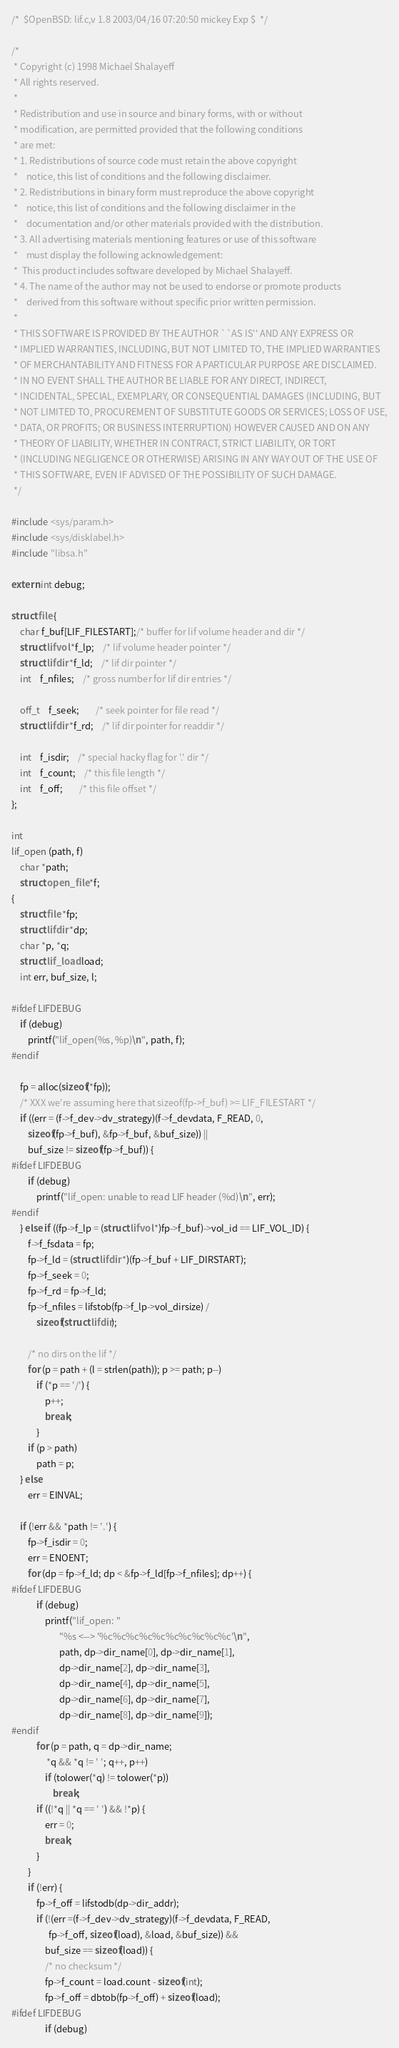<code> <loc_0><loc_0><loc_500><loc_500><_C_>/*	$OpenBSD: lif.c,v 1.8 2003/04/16 07:20:50 mickey Exp $	*/

/*
 * Copyright (c) 1998 Michael Shalayeff
 * All rights reserved.
 *
 * Redistribution and use in source and binary forms, with or without
 * modification, are permitted provided that the following conditions
 * are met:
 * 1. Redistributions of source code must retain the above copyright
 *    notice, this list of conditions and the following disclaimer.
 * 2. Redistributions in binary form must reproduce the above copyright
 *    notice, this list of conditions and the following disclaimer in the
 *    documentation and/or other materials provided with the distribution.
 * 3. All advertising materials mentioning features or use of this software
 *    must display the following acknowledgement:
 *	This product includes software developed by Michael Shalayeff.
 * 4. The name of the author may not be used to endorse or promote products
 *    derived from this software without specific prior written permission.
 *
 * THIS SOFTWARE IS PROVIDED BY THE AUTHOR ``AS IS'' AND ANY EXPRESS OR
 * IMPLIED WARRANTIES, INCLUDING, BUT NOT LIMITED TO, THE IMPLIED WARRANTIES
 * OF MERCHANTABILITY AND FITNESS FOR A PARTICULAR PURPOSE ARE DISCLAIMED.
 * IN NO EVENT SHALL THE AUTHOR BE LIABLE FOR ANY DIRECT, INDIRECT,
 * INCIDENTAL, SPECIAL, EXEMPLARY, OR CONSEQUENTIAL DAMAGES (INCLUDING, BUT
 * NOT LIMITED TO, PROCUREMENT OF SUBSTITUTE GOODS OR SERVICES; LOSS OF USE,
 * DATA, OR PROFITS; OR BUSINESS INTERRUPTION) HOWEVER CAUSED AND ON ANY
 * THEORY OF LIABILITY, WHETHER IN CONTRACT, STRICT LIABILITY, OR TORT
 * (INCLUDING NEGLIGENCE OR OTHERWISE) ARISING IN ANY WAY OUT OF THE USE OF
 * THIS SOFTWARE, EVEN IF ADVISED OF THE POSSIBILITY OF SUCH DAMAGE.
 */

#include <sys/param.h>
#include <sys/disklabel.h>
#include "libsa.h"

extern int debug;

struct file {
	char f_buf[LIF_FILESTART];/* buffer for lif volume header and dir */
	struct lifvol *f_lp;	/* lif volume header pointer */
	struct lifdir *f_ld;	/* lif dir pointer */
	int	f_nfiles;	/* gross number for lif dir entries */

	off_t	f_seek;		/* seek pointer for file read */
	struct lifdir *f_rd;	/* lif dir pointer for readdir */

	int	f_isdir;	/* special hacky flag for '.' dir */
	int	f_count;	/* this file length */
	int	f_off;		/* this file offset */
};

int
lif_open (path, f)
	char *path;
	struct open_file *f;
{
	struct file *fp;
	struct lifdir *dp;
	char *p, *q;
	struct lif_load load;
	int err, buf_size, l;

#ifdef LIFDEBUG
	if (debug)
		printf("lif_open(%s, %p)\n", path, f);
#endif

	fp = alloc(sizeof(*fp));
	/* XXX we're assuming here that sizeof(fp->f_buf) >= LIF_FILESTART */
	if ((err = (f->f_dev->dv_strategy)(f->f_devdata, F_READ, 0,
	    sizeof(fp->f_buf), &fp->f_buf, &buf_size)) ||
	    buf_size != sizeof(fp->f_buf)) {
#ifdef LIFDEBUG
		if (debug)
			printf("lif_open: unable to read LIF header (%d)\n", err);
#endif
	} else if ((fp->f_lp = (struct lifvol *)fp->f_buf)->vol_id == LIF_VOL_ID) {
		f->f_fsdata = fp;
		fp->f_ld = (struct lifdir *)(fp->f_buf + LIF_DIRSTART);
		fp->f_seek = 0;
		fp->f_rd = fp->f_ld;
		fp->f_nfiles = lifstob(fp->f_lp->vol_dirsize) /
			sizeof(struct lifdir);

		/* no dirs on the lif */
		for (p = path + (l = strlen(path)); p >= path; p--)
			if (*p == '/') {
				p++;
				break;
			}
		if (p > path)
			path = p;
	} else
		err = EINVAL;

	if (!err && *path != '.') {
		fp->f_isdir = 0;
		err = ENOENT;
		for (dp = fp->f_ld; dp < &fp->f_ld[fp->f_nfiles]; dp++) {
#ifdef LIFDEBUG
			if (debug)
				printf("lif_open: "
				       "%s <--> '%c%c%c%c%c%c%c%c%c%c'\n",
				       path, dp->dir_name[0], dp->dir_name[1],
				       dp->dir_name[2], dp->dir_name[3],
				       dp->dir_name[4], dp->dir_name[5],
				       dp->dir_name[6], dp->dir_name[7],
				       dp->dir_name[8], dp->dir_name[9]);
#endif
			for (p = path, q = dp->dir_name;
			     *q && *q != ' '; q++, p++)
				if (tolower(*q) != tolower(*p))
					break;
			if ((!*q || *q == ' ') && !*p) {
				err = 0;
				break;
			}
		}
		if (!err) {
			fp->f_off = lifstodb(dp->dir_addr);
			if (!(err =(f->f_dev->dv_strategy)(f->f_devdata, F_READ,
			      fp->f_off, sizeof(load), &load, &buf_size)) &&
			    buf_size == sizeof(load)) {
				/* no checksum */
				fp->f_count = load.count - sizeof(int);
				fp->f_off = dbtob(fp->f_off) + sizeof(load);
#ifdef LIFDEBUG
				if (debug)</code> 